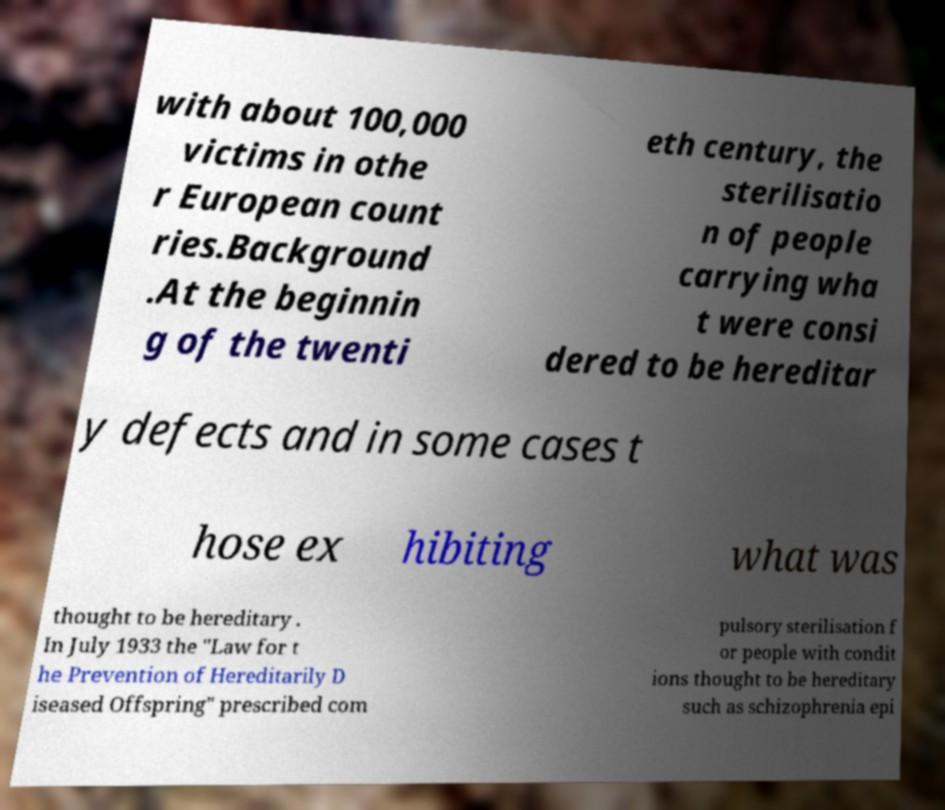There's text embedded in this image that I need extracted. Can you transcribe it verbatim? with about 100,000 victims in othe r European count ries.Background .At the beginnin g of the twenti eth century, the sterilisatio n of people carrying wha t were consi dered to be hereditar y defects and in some cases t hose ex hibiting what was thought to be hereditary . In July 1933 the "Law for t he Prevention of Hereditarily D iseased Offspring" prescribed com pulsory sterilisation f or people with condit ions thought to be hereditary such as schizophrenia epi 